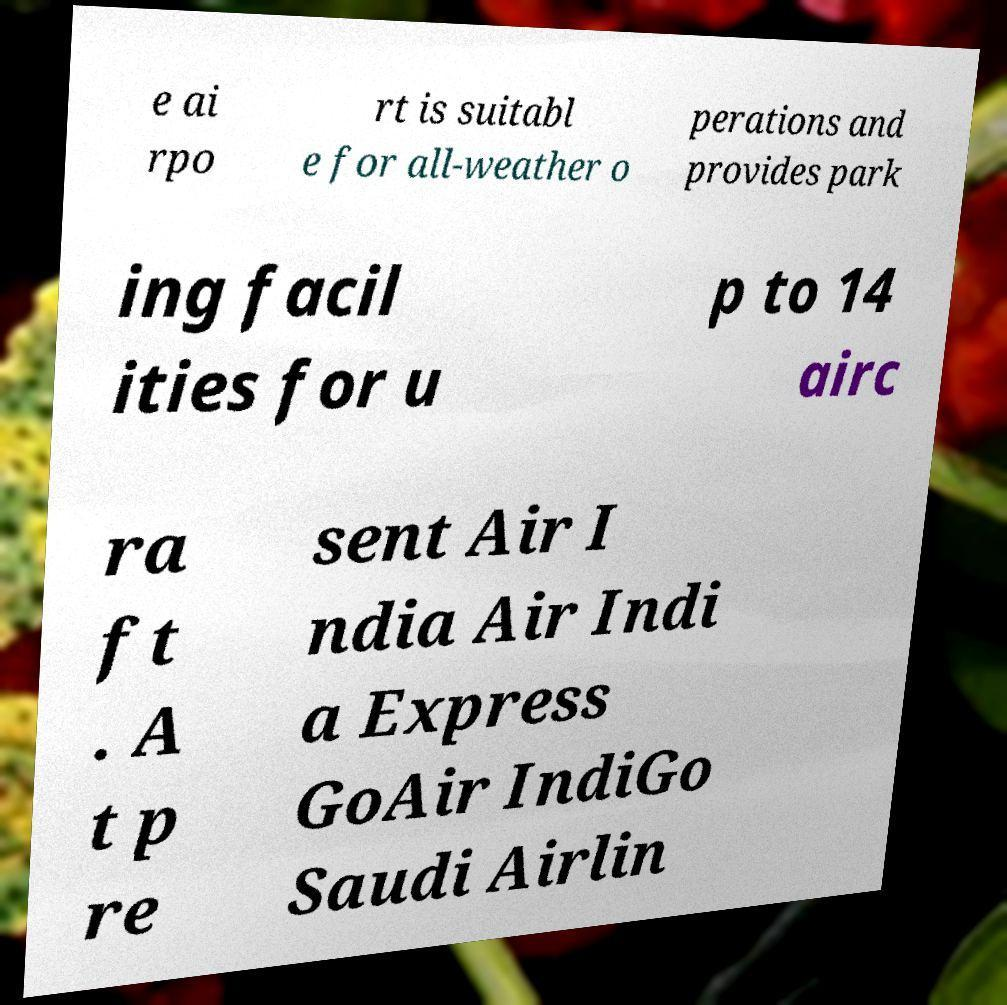There's text embedded in this image that I need extracted. Can you transcribe it verbatim? e ai rpo rt is suitabl e for all-weather o perations and provides park ing facil ities for u p to 14 airc ra ft . A t p re sent Air I ndia Air Indi a Express GoAir IndiGo Saudi Airlin 